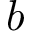Convert formula to latex. <formula><loc_0><loc_0><loc_500><loc_500>b</formula> 